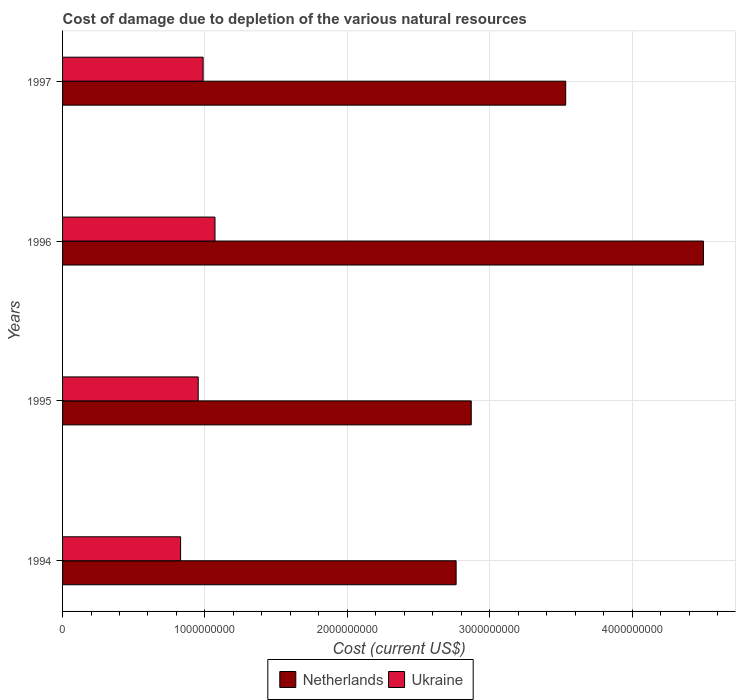How many different coloured bars are there?
Provide a short and direct response. 2. How many groups of bars are there?
Offer a terse response. 4. Are the number of bars per tick equal to the number of legend labels?
Your response must be concise. Yes. In how many cases, is the number of bars for a given year not equal to the number of legend labels?
Your answer should be very brief. 0. What is the cost of damage caused due to the depletion of various natural resources in Netherlands in 1995?
Make the answer very short. 2.87e+09. Across all years, what is the maximum cost of damage caused due to the depletion of various natural resources in Netherlands?
Provide a short and direct response. 4.50e+09. Across all years, what is the minimum cost of damage caused due to the depletion of various natural resources in Ukraine?
Give a very brief answer. 8.29e+08. What is the total cost of damage caused due to the depletion of various natural resources in Netherlands in the graph?
Your response must be concise. 1.37e+1. What is the difference between the cost of damage caused due to the depletion of various natural resources in Netherlands in 1995 and that in 1997?
Your response must be concise. -6.63e+08. What is the difference between the cost of damage caused due to the depletion of various natural resources in Netherlands in 1994 and the cost of damage caused due to the depletion of various natural resources in Ukraine in 1996?
Ensure brevity in your answer.  1.69e+09. What is the average cost of damage caused due to the depletion of various natural resources in Ukraine per year?
Ensure brevity in your answer.  9.60e+08. In the year 1997, what is the difference between the cost of damage caused due to the depletion of various natural resources in Netherlands and cost of damage caused due to the depletion of various natural resources in Ukraine?
Provide a succinct answer. 2.55e+09. What is the ratio of the cost of damage caused due to the depletion of various natural resources in Ukraine in 1994 to that in 1997?
Your response must be concise. 0.84. Is the cost of damage caused due to the depletion of various natural resources in Ukraine in 1996 less than that in 1997?
Give a very brief answer. No. Is the difference between the cost of damage caused due to the depletion of various natural resources in Netherlands in 1994 and 1996 greater than the difference between the cost of damage caused due to the depletion of various natural resources in Ukraine in 1994 and 1996?
Your answer should be very brief. No. What is the difference between the highest and the second highest cost of damage caused due to the depletion of various natural resources in Netherlands?
Provide a succinct answer. 9.68e+08. What is the difference between the highest and the lowest cost of damage caused due to the depletion of various natural resources in Ukraine?
Provide a short and direct response. 2.42e+08. In how many years, is the cost of damage caused due to the depletion of various natural resources in Netherlands greater than the average cost of damage caused due to the depletion of various natural resources in Netherlands taken over all years?
Offer a terse response. 2. What does the 1st bar from the bottom in 1994 represents?
Your response must be concise. Netherlands. How many bars are there?
Offer a terse response. 8. How many years are there in the graph?
Your answer should be very brief. 4. Are the values on the major ticks of X-axis written in scientific E-notation?
Your answer should be compact. No. Does the graph contain any zero values?
Your response must be concise. No. How are the legend labels stacked?
Your answer should be compact. Horizontal. What is the title of the graph?
Provide a succinct answer. Cost of damage due to depletion of the various natural resources. What is the label or title of the X-axis?
Offer a terse response. Cost (current US$). What is the label or title of the Y-axis?
Ensure brevity in your answer.  Years. What is the Cost (current US$) in Netherlands in 1994?
Your response must be concise. 2.76e+09. What is the Cost (current US$) of Ukraine in 1994?
Offer a very short reply. 8.29e+08. What is the Cost (current US$) of Netherlands in 1995?
Your response must be concise. 2.87e+09. What is the Cost (current US$) of Ukraine in 1995?
Offer a very short reply. 9.53e+08. What is the Cost (current US$) in Netherlands in 1996?
Provide a short and direct response. 4.50e+09. What is the Cost (current US$) in Ukraine in 1996?
Your answer should be very brief. 1.07e+09. What is the Cost (current US$) of Netherlands in 1997?
Give a very brief answer. 3.53e+09. What is the Cost (current US$) in Ukraine in 1997?
Provide a succinct answer. 9.87e+08. Across all years, what is the maximum Cost (current US$) in Netherlands?
Your answer should be compact. 4.50e+09. Across all years, what is the maximum Cost (current US$) in Ukraine?
Make the answer very short. 1.07e+09. Across all years, what is the minimum Cost (current US$) in Netherlands?
Offer a terse response. 2.76e+09. Across all years, what is the minimum Cost (current US$) of Ukraine?
Give a very brief answer. 8.29e+08. What is the total Cost (current US$) of Netherlands in the graph?
Ensure brevity in your answer.  1.37e+1. What is the total Cost (current US$) in Ukraine in the graph?
Your answer should be very brief. 3.84e+09. What is the difference between the Cost (current US$) of Netherlands in 1994 and that in 1995?
Provide a succinct answer. -1.06e+08. What is the difference between the Cost (current US$) of Ukraine in 1994 and that in 1995?
Keep it short and to the point. -1.24e+08. What is the difference between the Cost (current US$) of Netherlands in 1994 and that in 1996?
Ensure brevity in your answer.  -1.74e+09. What is the difference between the Cost (current US$) in Ukraine in 1994 and that in 1996?
Ensure brevity in your answer.  -2.42e+08. What is the difference between the Cost (current US$) in Netherlands in 1994 and that in 1997?
Provide a short and direct response. -7.70e+08. What is the difference between the Cost (current US$) of Ukraine in 1994 and that in 1997?
Make the answer very short. -1.58e+08. What is the difference between the Cost (current US$) of Netherlands in 1995 and that in 1996?
Provide a short and direct response. -1.63e+09. What is the difference between the Cost (current US$) of Ukraine in 1995 and that in 1996?
Your answer should be very brief. -1.18e+08. What is the difference between the Cost (current US$) in Netherlands in 1995 and that in 1997?
Offer a very short reply. -6.63e+08. What is the difference between the Cost (current US$) in Ukraine in 1995 and that in 1997?
Keep it short and to the point. -3.46e+07. What is the difference between the Cost (current US$) in Netherlands in 1996 and that in 1997?
Offer a terse response. 9.68e+08. What is the difference between the Cost (current US$) in Ukraine in 1996 and that in 1997?
Ensure brevity in your answer.  8.34e+07. What is the difference between the Cost (current US$) in Netherlands in 1994 and the Cost (current US$) in Ukraine in 1995?
Keep it short and to the point. 1.81e+09. What is the difference between the Cost (current US$) in Netherlands in 1994 and the Cost (current US$) in Ukraine in 1996?
Your answer should be compact. 1.69e+09. What is the difference between the Cost (current US$) in Netherlands in 1994 and the Cost (current US$) in Ukraine in 1997?
Keep it short and to the point. 1.78e+09. What is the difference between the Cost (current US$) in Netherlands in 1995 and the Cost (current US$) in Ukraine in 1996?
Your response must be concise. 1.80e+09. What is the difference between the Cost (current US$) in Netherlands in 1995 and the Cost (current US$) in Ukraine in 1997?
Your answer should be compact. 1.88e+09. What is the difference between the Cost (current US$) in Netherlands in 1996 and the Cost (current US$) in Ukraine in 1997?
Offer a terse response. 3.51e+09. What is the average Cost (current US$) in Netherlands per year?
Make the answer very short. 3.42e+09. What is the average Cost (current US$) in Ukraine per year?
Give a very brief answer. 9.60e+08. In the year 1994, what is the difference between the Cost (current US$) of Netherlands and Cost (current US$) of Ukraine?
Provide a short and direct response. 1.94e+09. In the year 1995, what is the difference between the Cost (current US$) in Netherlands and Cost (current US$) in Ukraine?
Your answer should be very brief. 1.92e+09. In the year 1996, what is the difference between the Cost (current US$) of Netherlands and Cost (current US$) of Ukraine?
Give a very brief answer. 3.43e+09. In the year 1997, what is the difference between the Cost (current US$) of Netherlands and Cost (current US$) of Ukraine?
Your response must be concise. 2.55e+09. What is the ratio of the Cost (current US$) in Netherlands in 1994 to that in 1995?
Keep it short and to the point. 0.96. What is the ratio of the Cost (current US$) of Ukraine in 1994 to that in 1995?
Your response must be concise. 0.87. What is the ratio of the Cost (current US$) in Netherlands in 1994 to that in 1996?
Your response must be concise. 0.61. What is the ratio of the Cost (current US$) of Ukraine in 1994 to that in 1996?
Your response must be concise. 0.77. What is the ratio of the Cost (current US$) in Netherlands in 1994 to that in 1997?
Make the answer very short. 0.78. What is the ratio of the Cost (current US$) of Ukraine in 1994 to that in 1997?
Offer a very short reply. 0.84. What is the ratio of the Cost (current US$) of Netherlands in 1995 to that in 1996?
Offer a very short reply. 0.64. What is the ratio of the Cost (current US$) in Ukraine in 1995 to that in 1996?
Give a very brief answer. 0.89. What is the ratio of the Cost (current US$) in Netherlands in 1995 to that in 1997?
Offer a terse response. 0.81. What is the ratio of the Cost (current US$) in Netherlands in 1996 to that in 1997?
Make the answer very short. 1.27. What is the ratio of the Cost (current US$) in Ukraine in 1996 to that in 1997?
Offer a very short reply. 1.08. What is the difference between the highest and the second highest Cost (current US$) of Netherlands?
Provide a succinct answer. 9.68e+08. What is the difference between the highest and the second highest Cost (current US$) of Ukraine?
Your answer should be very brief. 8.34e+07. What is the difference between the highest and the lowest Cost (current US$) in Netherlands?
Your response must be concise. 1.74e+09. What is the difference between the highest and the lowest Cost (current US$) of Ukraine?
Your answer should be very brief. 2.42e+08. 